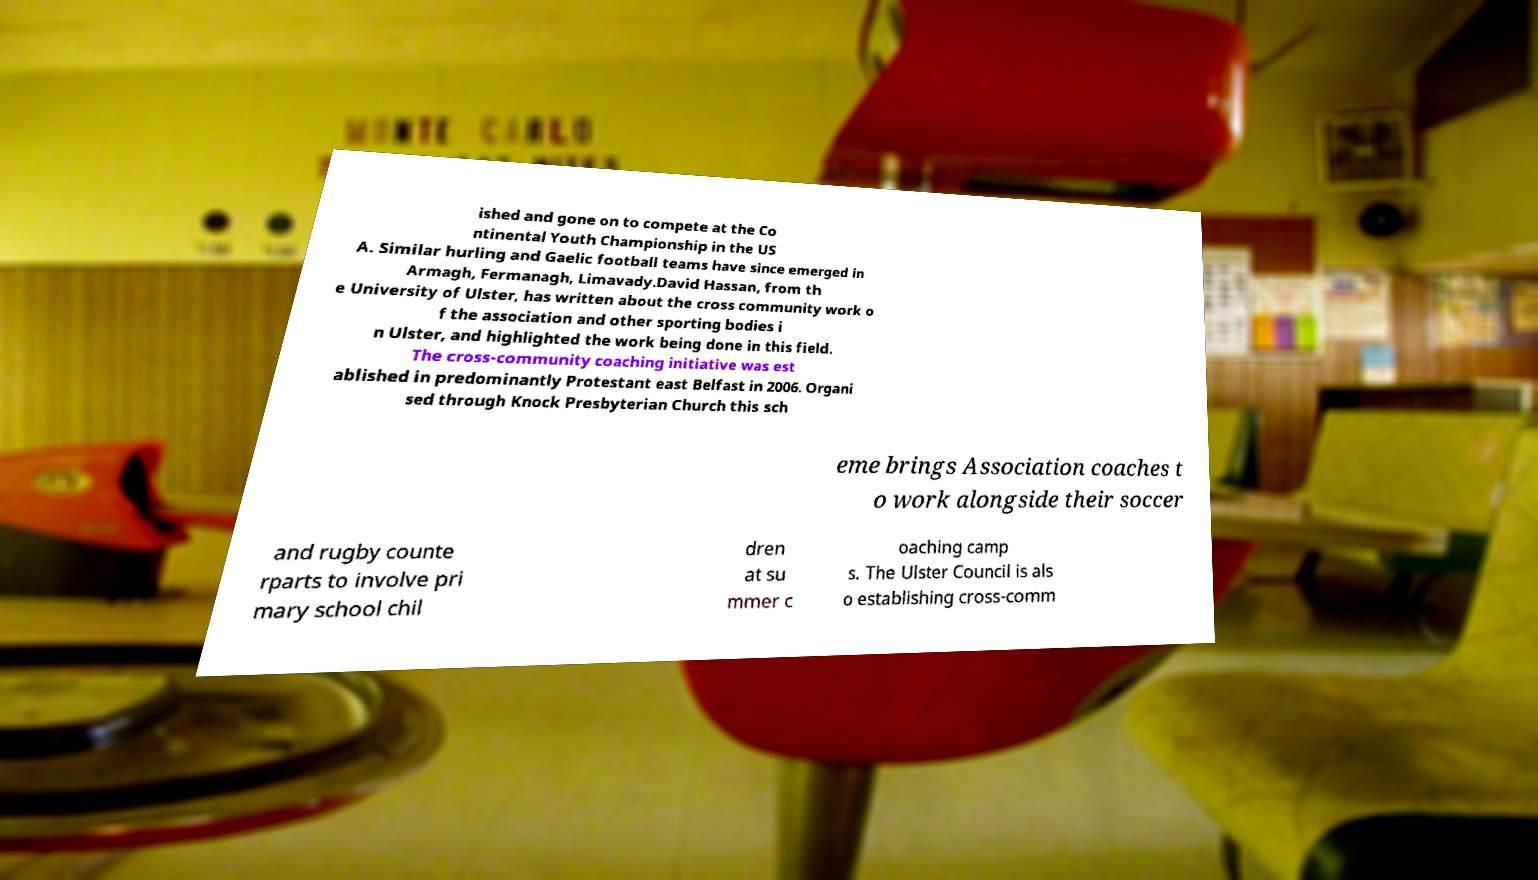Please read and relay the text visible in this image. What does it say? ished and gone on to compete at the Co ntinental Youth Championship in the US A. Similar hurling and Gaelic football teams have since emerged in Armagh, Fermanagh, Limavady.David Hassan, from th e University of Ulster, has written about the cross community work o f the association and other sporting bodies i n Ulster, and highlighted the work being done in this field. The cross-community coaching initiative was est ablished in predominantly Protestant east Belfast in 2006. Organi sed through Knock Presbyterian Church this sch eme brings Association coaches t o work alongside their soccer and rugby counte rparts to involve pri mary school chil dren at su mmer c oaching camp s. The Ulster Council is als o establishing cross-comm 